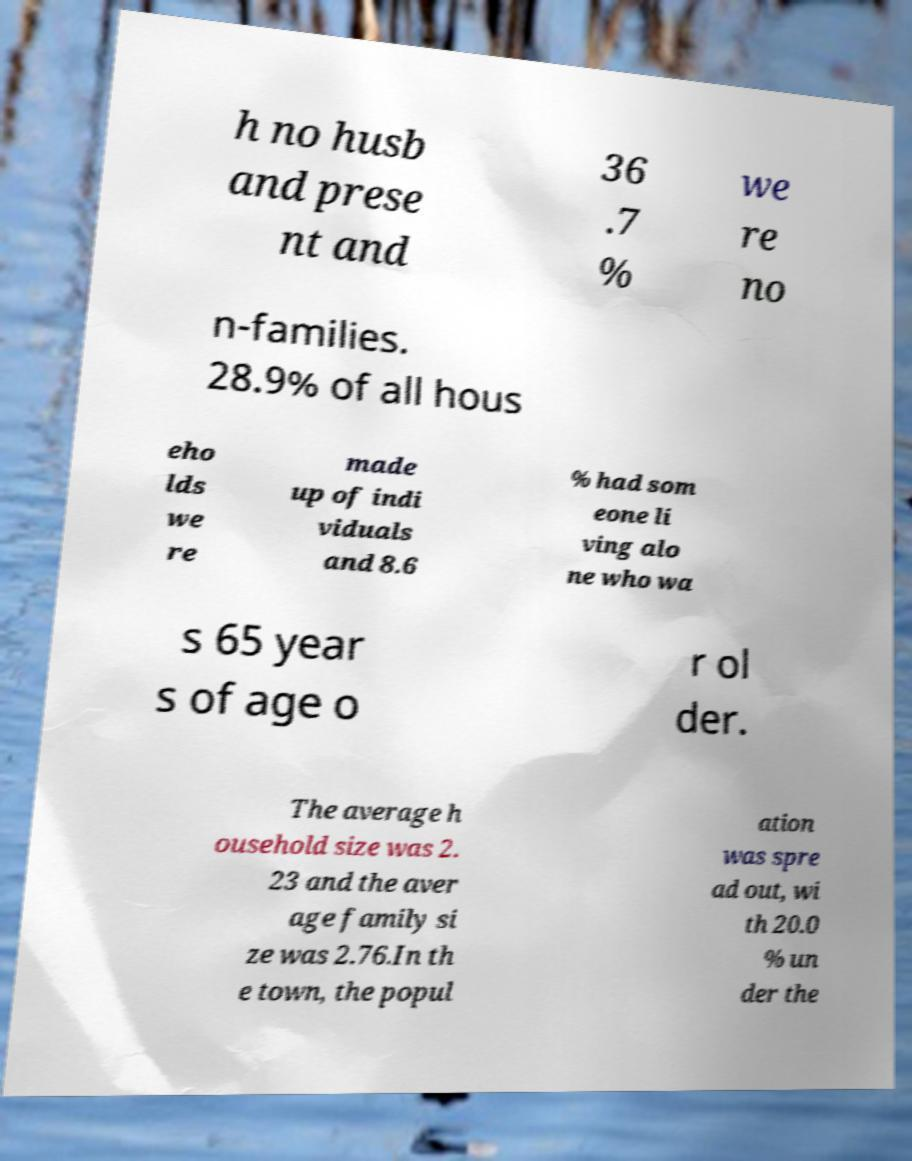I need the written content from this picture converted into text. Can you do that? h no husb and prese nt and 36 .7 % we re no n-families. 28.9% of all hous eho lds we re made up of indi viduals and 8.6 % had som eone li ving alo ne who wa s 65 year s of age o r ol der. The average h ousehold size was 2. 23 and the aver age family si ze was 2.76.In th e town, the popul ation was spre ad out, wi th 20.0 % un der the 